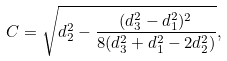Convert formula to latex. <formula><loc_0><loc_0><loc_500><loc_500>C = \sqrt { d _ { 2 } ^ { 2 } - \frac { ( d _ { 3 } ^ { 2 } - d _ { 1 } ^ { 2 } ) ^ { 2 } } { 8 ( d _ { 3 } ^ { 2 } + d _ { 1 } ^ { 2 } - 2 d _ { 2 } ^ { 2 } ) } } ,</formula> 